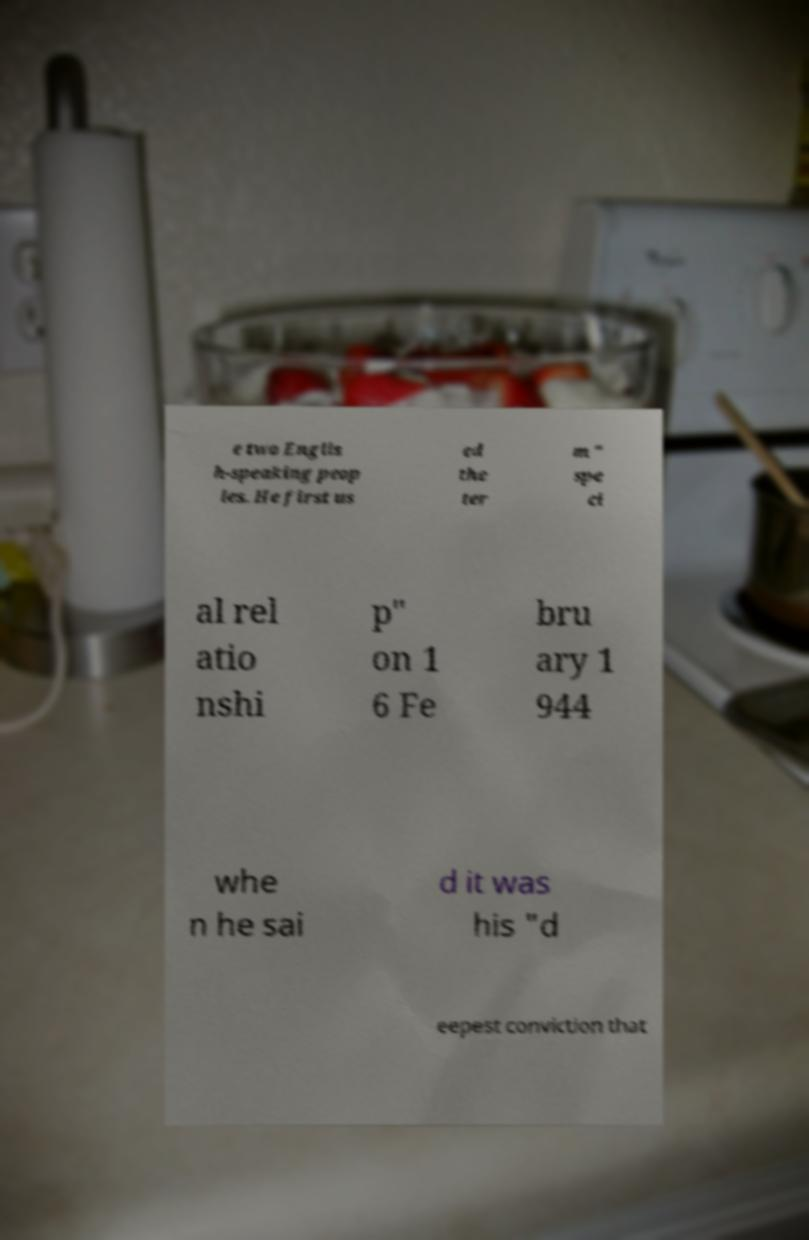What messages or text are displayed in this image? I need them in a readable, typed format. e two Englis h-speaking peop les. He first us ed the ter m " spe ci al rel atio nshi p" on 1 6 Fe bru ary 1 944 whe n he sai d it was his "d eepest conviction that 